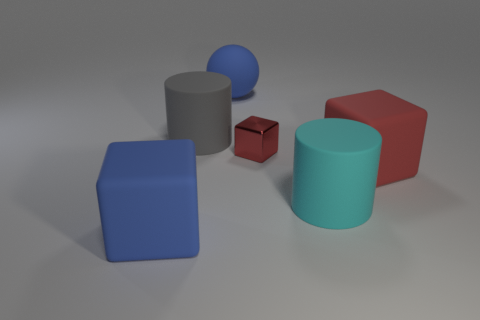Subtract all large matte cubes. How many cubes are left? 1 Add 4 big gray rubber cubes. How many objects exist? 10 Subtract all gray cylinders. How many cylinders are left? 1 Subtract all spheres. How many objects are left? 5 Subtract 1 cubes. How many cubes are left? 2 Subtract 0 purple balls. How many objects are left? 6 Subtract all purple cubes. Subtract all brown balls. How many cubes are left? 3 Subtract all cyan cylinders. How many blue blocks are left? 1 Subtract all gray objects. Subtract all green cubes. How many objects are left? 5 Add 6 cyan things. How many cyan things are left? 7 